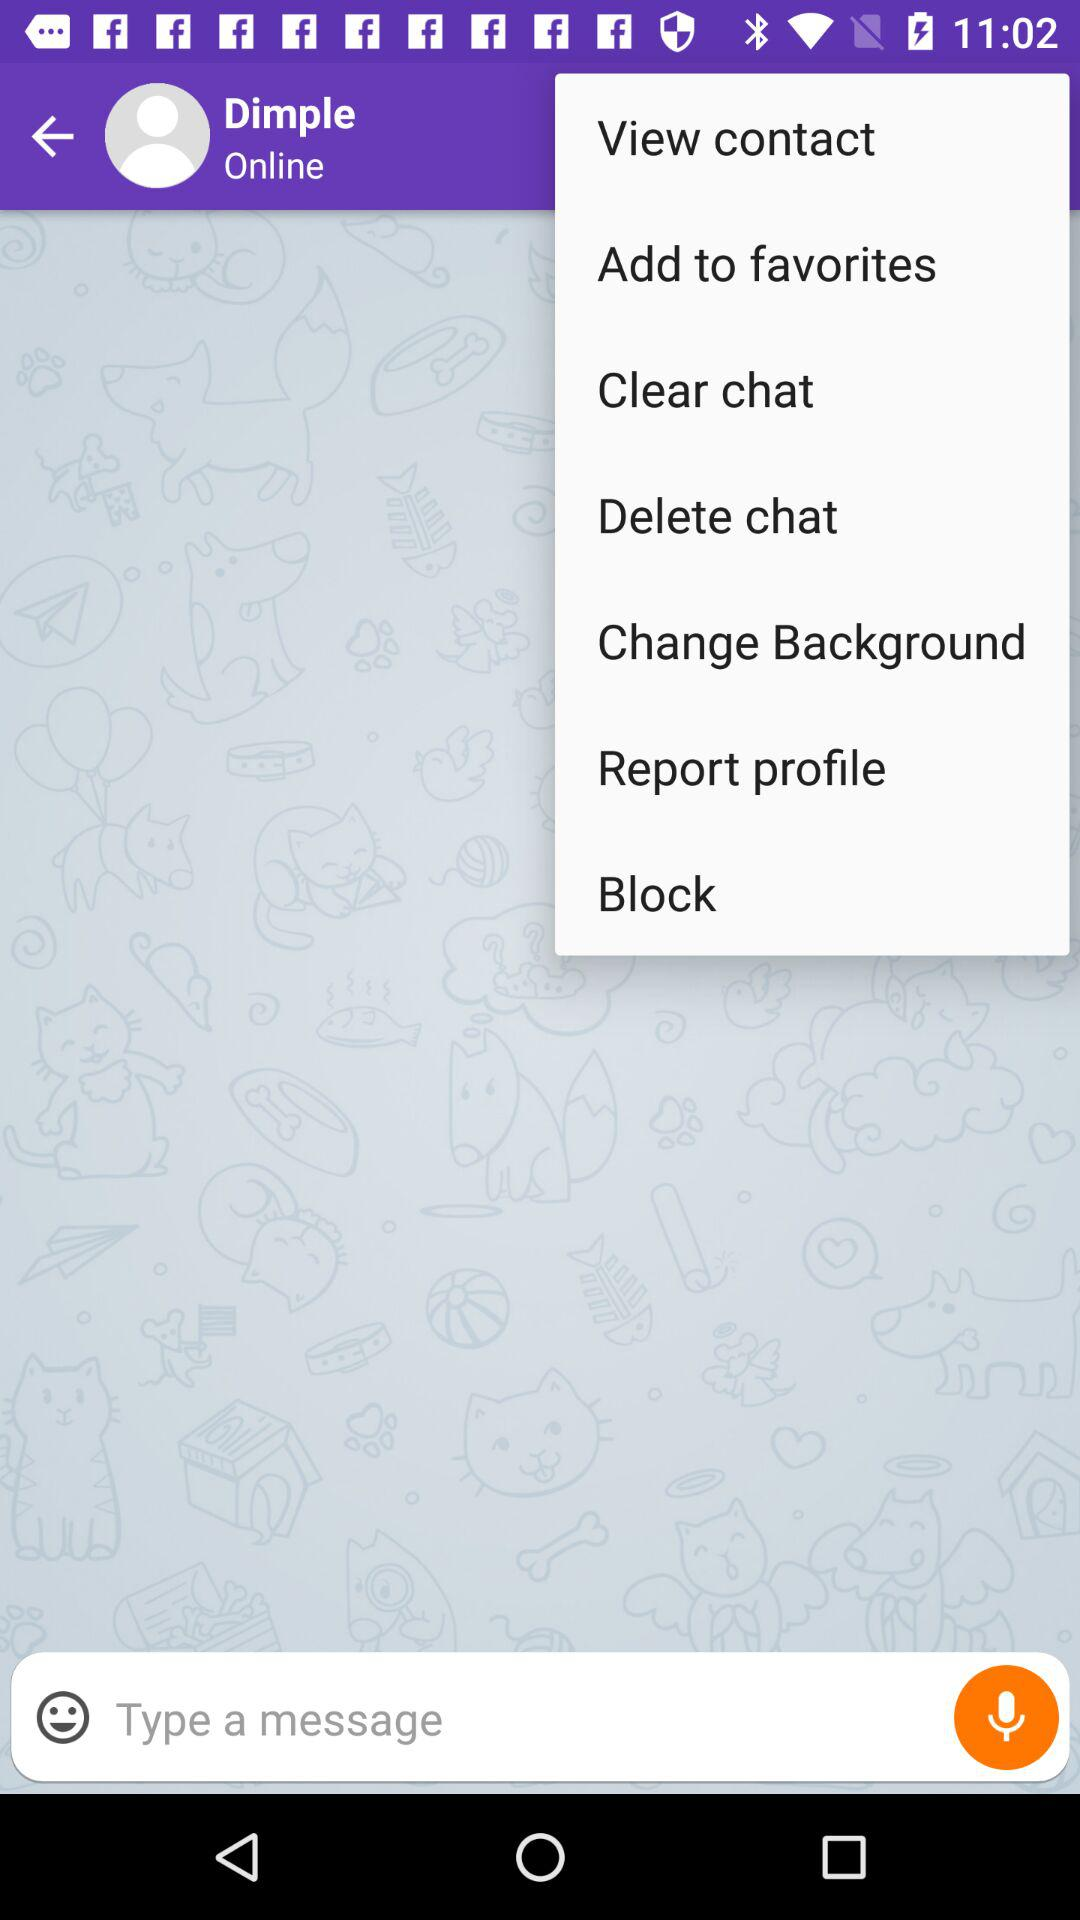What is the name of the user? The name of the user is Dimple. 